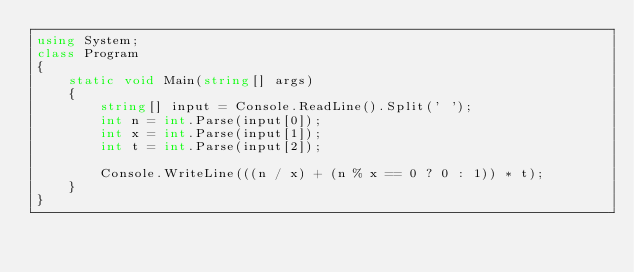<code> <loc_0><loc_0><loc_500><loc_500><_C#_>using System;
class Program
{
    static void Main(string[] args)
    {
        string[] input = Console.ReadLine().Split(' ');
        int n = int.Parse(input[0]);
        int x = int.Parse(input[1]);
        int t = int.Parse(input[2]);

        Console.WriteLine(((n / x) + (n % x == 0 ? 0 : 1)) * t);
    }
}</code> 